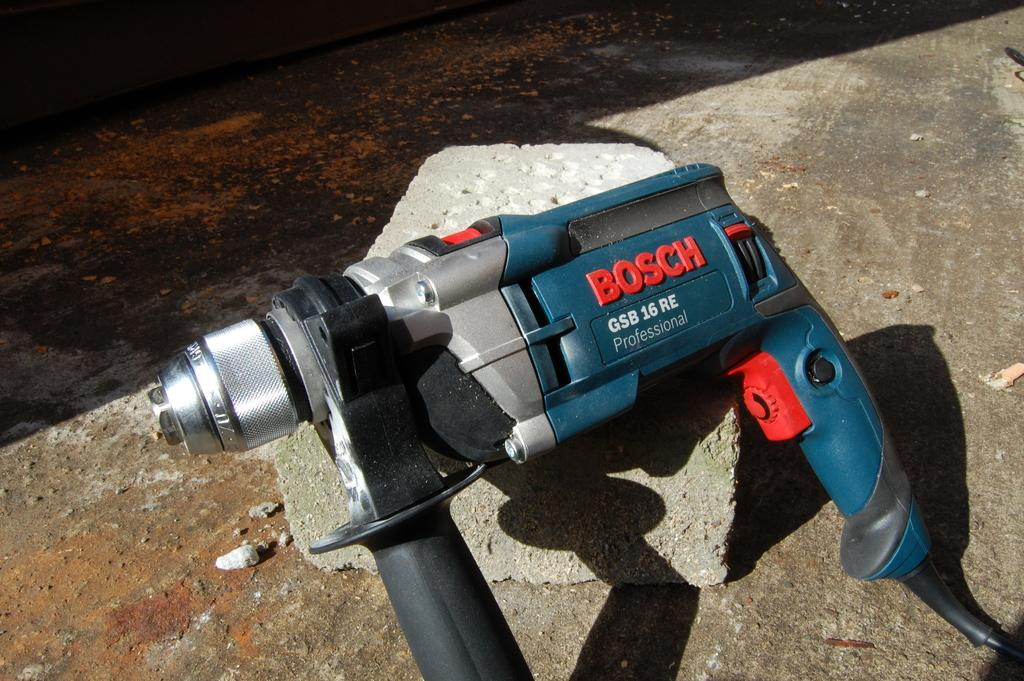What is the main object in the image? There is a drilling machine in the image. What is the drilling machine placed on? The drilling machine is on a stone. What type of surface can be seen in the image? There is a floor visible in the image. What type of surprise can be seen in the image? There is no surprise present in the image; it features a drilling machine on a stone with a visible floor. 